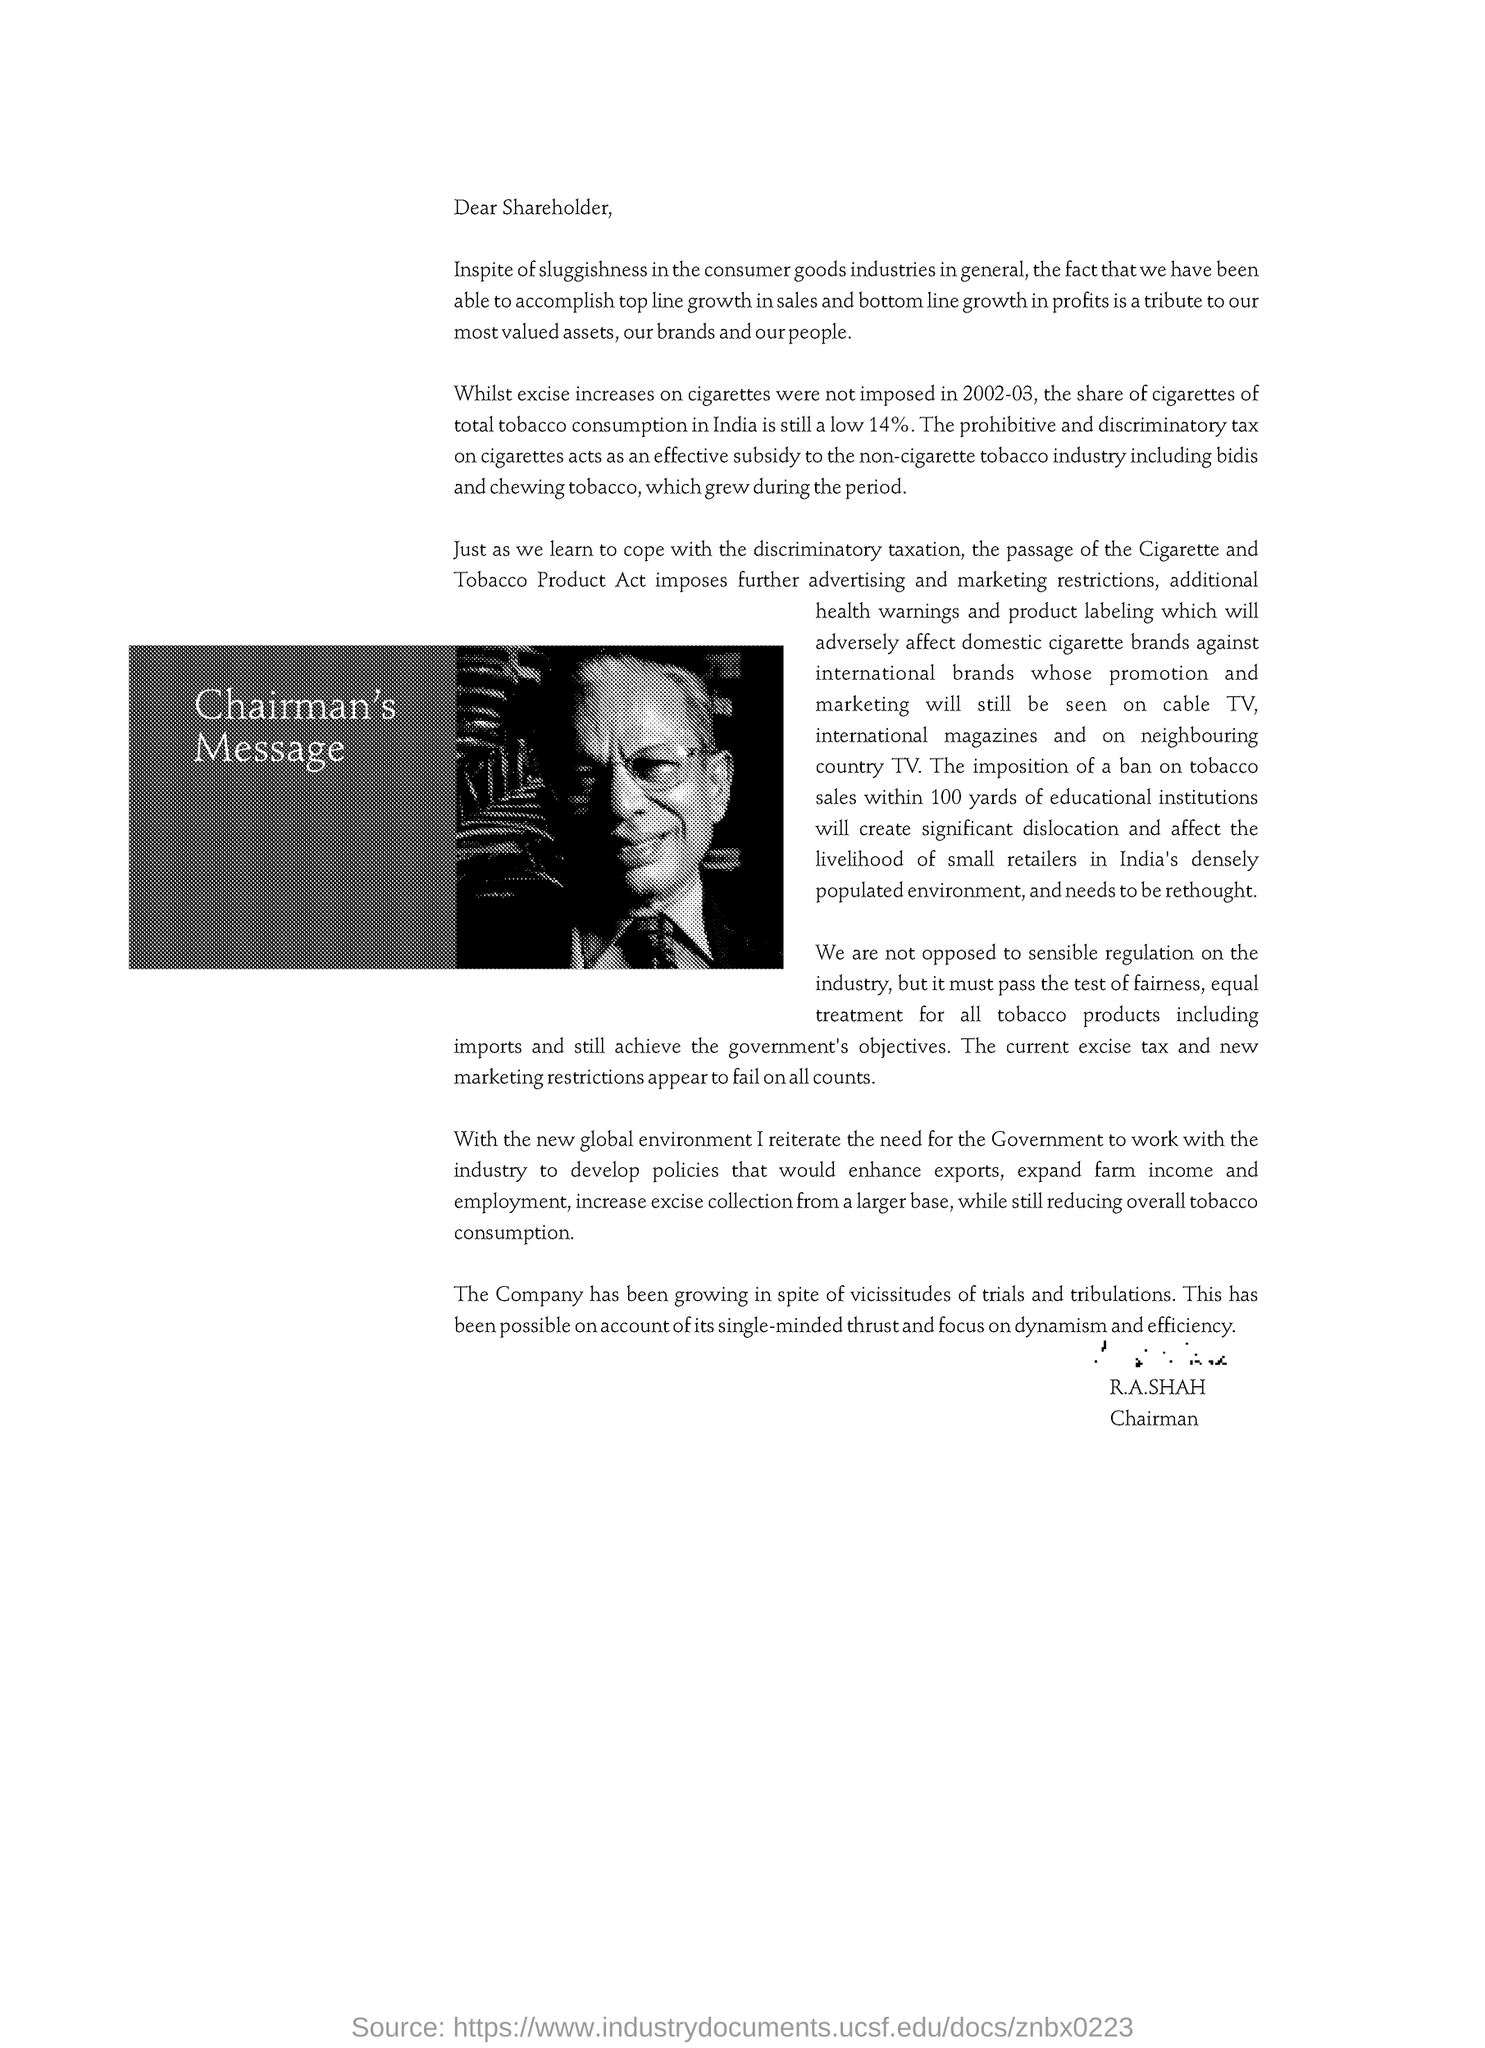Outline some significant characteristics in this image. The Chairman's name is R.A.SHAH. 